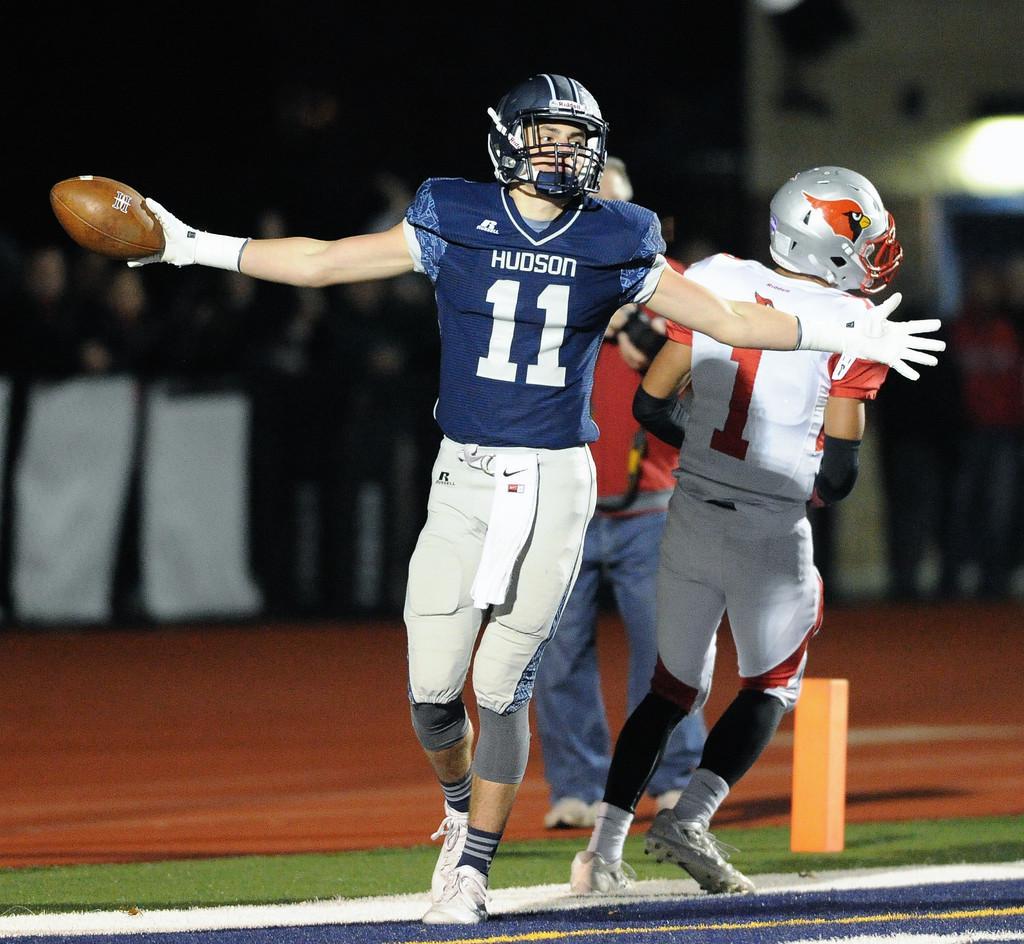Describe this image in one or two sentences. In front of the picture, the man in blue T-shirt who is wearing a black helmet is holding a football in his hand. Beside him, we see the man in white T-shirt is running. Behind him, we see a man in red T-shirt and blue jeans is standing. Beside them, we see a small wooden rod. In the background, we see people holding white color banners in their hands and they are standing. On the right side, we see the light and people are standing. In the background, it is black in color. This picture might be clicked in the football field. 